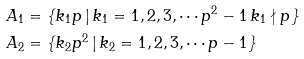<formula> <loc_0><loc_0><loc_500><loc_500>A _ { 1 } & = \{ k _ { 1 } p \, | \, k _ { 1 } = 1 , 2 , 3 , \cdots p ^ { 2 } - 1 \, k _ { 1 } \nmid p \} \\ A _ { 2 } & = \{ k _ { 2 } p ^ { 2 } \, | \, k _ { 2 } = 1 , 2 , 3 , \cdots p - 1 \}</formula> 